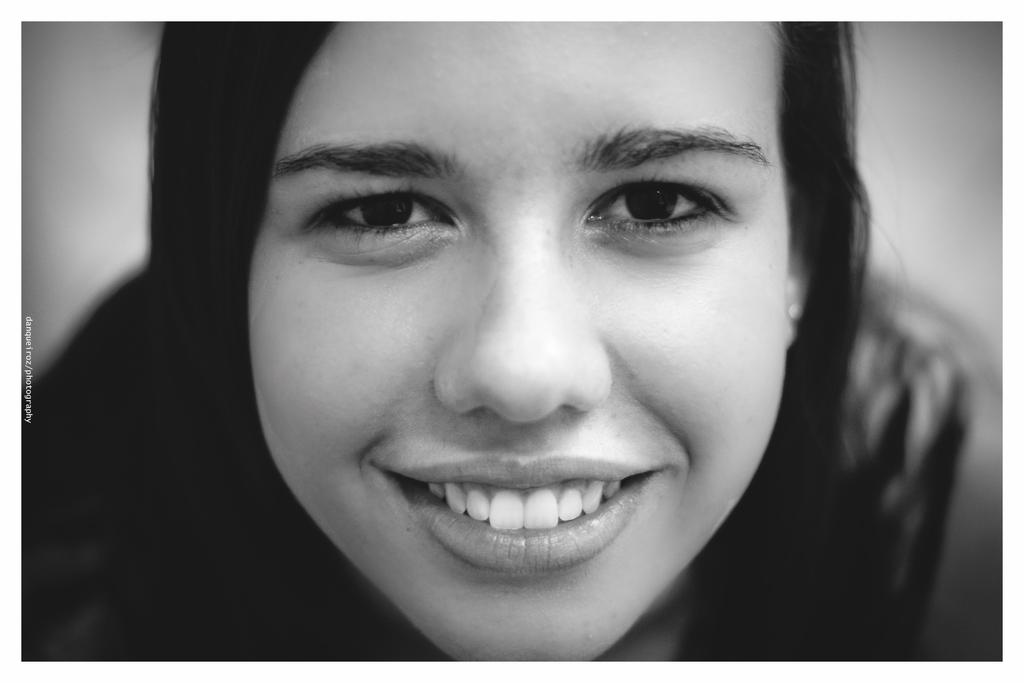Who is the main subject in the image? There is a lady in the image. What is the lady doing in the image? The lady is sitting. What is the lady's facial expression in the image? The lady is smiling. How does the lady attempt to answer the question without making a sound in the image? There is no indication in the image that the lady is attempting to answer a question or making any sound. 